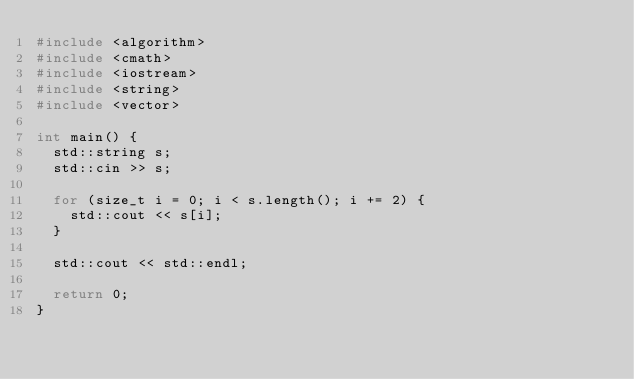Convert code to text. <code><loc_0><loc_0><loc_500><loc_500><_C++_>#include <algorithm>
#include <cmath>
#include <iostream>
#include <string>
#include <vector>

int main() {
  std::string s;
  std::cin >> s;

  for (size_t i = 0; i < s.length(); i += 2) {
    std::cout << s[i];
  }

  std::cout << std::endl;

  return 0;
}</code> 